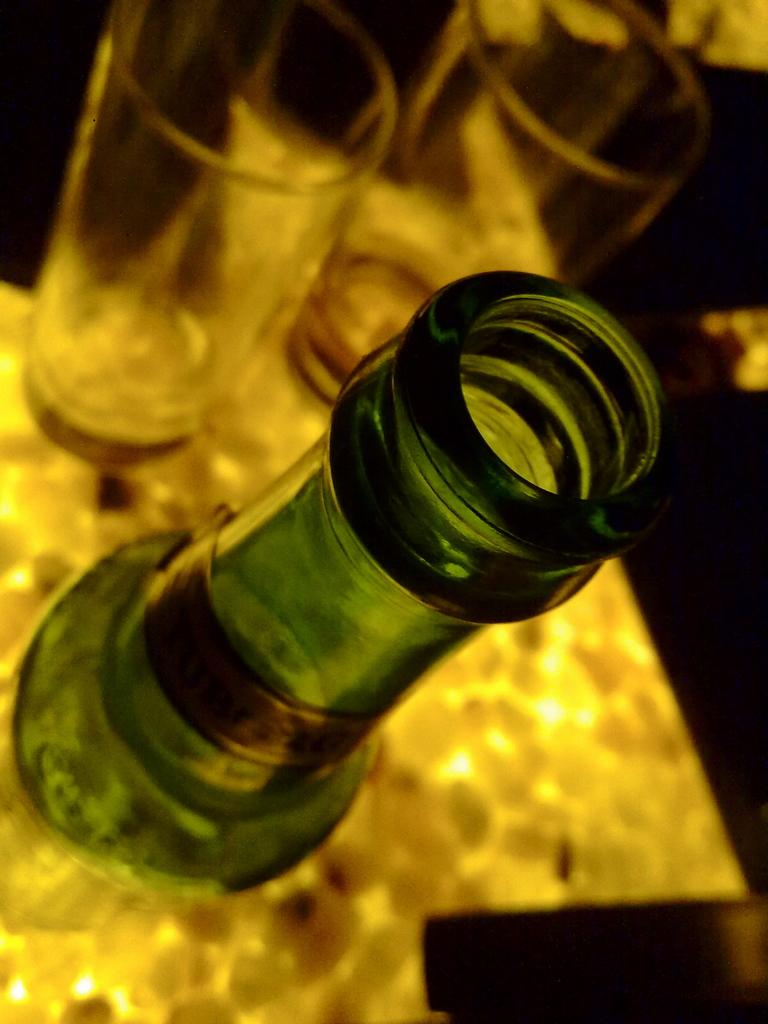What type of beverage container is visible in the image? There is a beer bottle in the image. Where is the beer bottle located? The beer bottle is on a table. How many glasses are present in the image? There are two glasses in the image. What type of invention is being demonstrated in the image? There is no invention being demonstrated in the image; it features a beer bottle, glasses, and a table. What type of game is being played in the image? There is no game being played in the image; it features a beer bottle, glasses, and a table. 